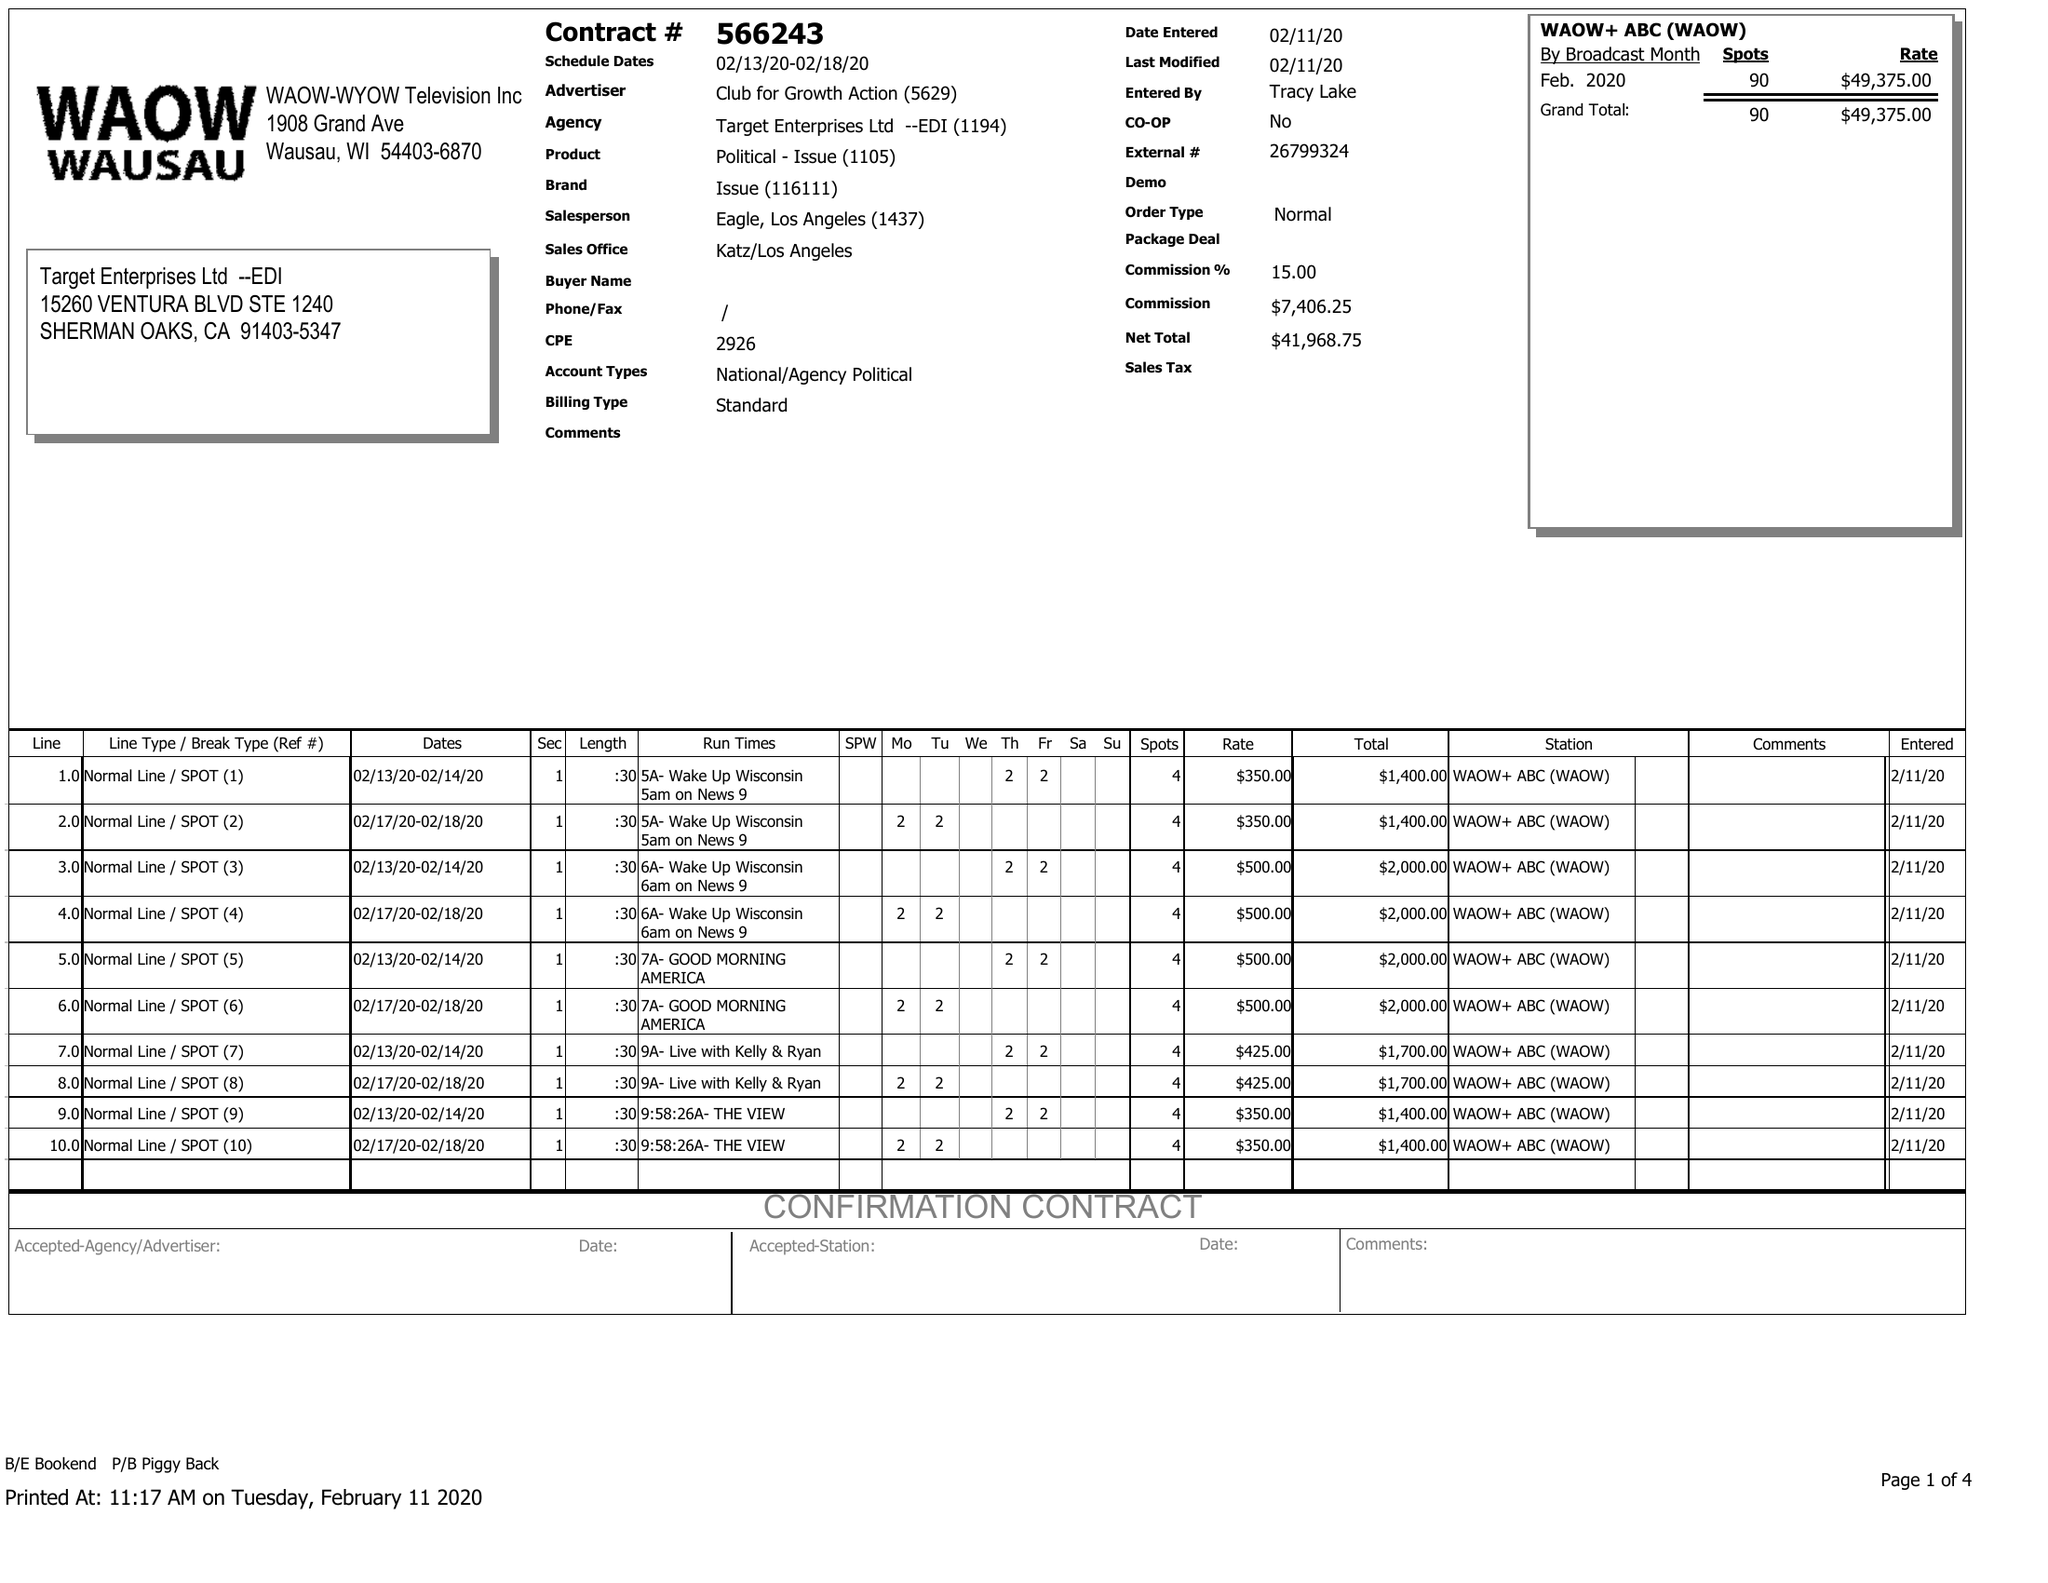What is the value for the contract_num?
Answer the question using a single word or phrase. 566243 